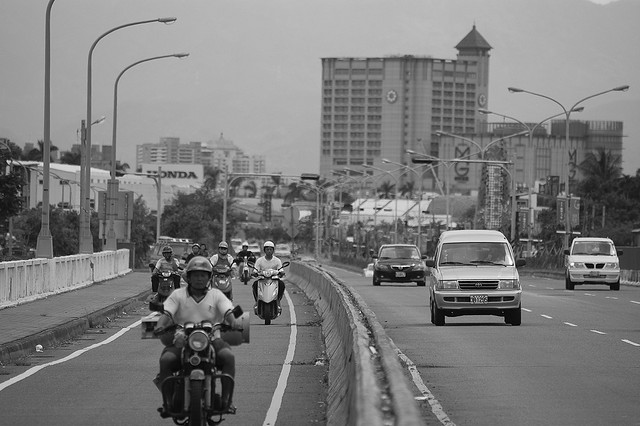<image>What kind of shoes is this cyclist wearing? I am not sure what kind of shoes the cyclist is wearing. It can be boots, sneakers or tennis shoes. What kind of shoes is this cyclist wearing? This cyclist is wearing boots. 